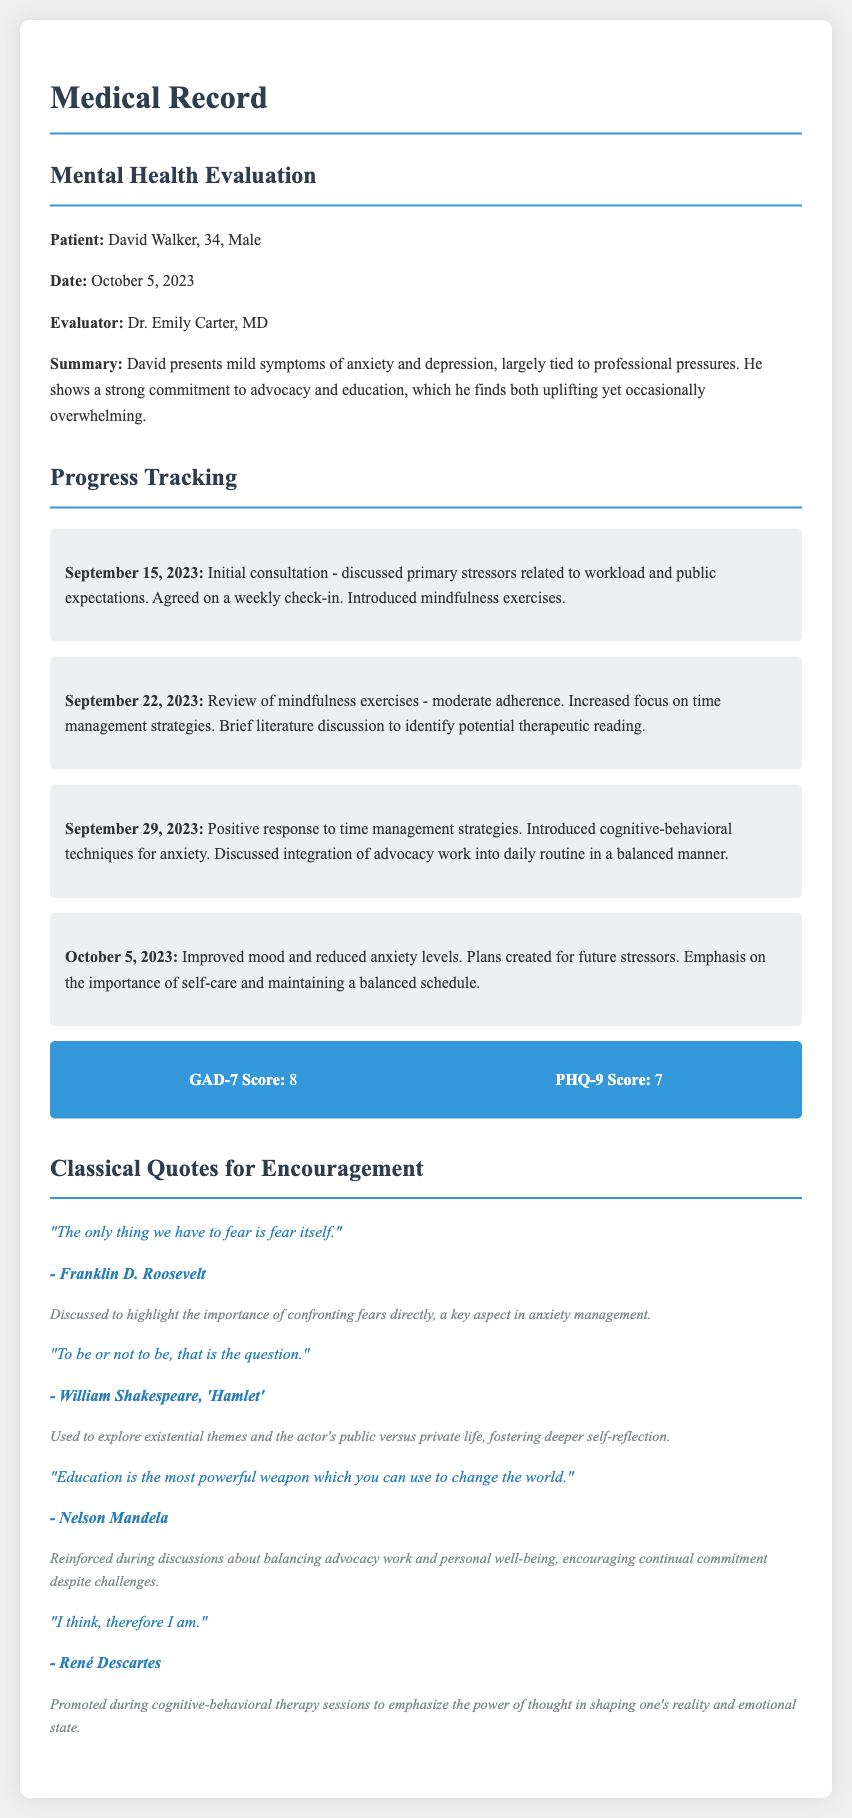What is the patient's name? The patient's name is mentioned in the evaluation section as David Walker.
Answer: David Walker Who conducted the mental health evaluation? The evaluator who conducted the mental health evaluation is noted in the document.
Answer: Dr. Emily Carter What was the GAD-7 score? The GAD-7 score is specifically listed in the scores section of the progress tracking.
Answer: 8 What date was the initial consultation? The date for the initial consultation is presented under the progress tracking section.
Answer: September 15, 2023 What is the main theme of the quote by Franklin D. Roosevelt? The quote by Franklin D. Roosevelt highlights the importance of confronting fears directly in anxiety management.
Answer: Confronting fears How did the patient's mood change by October 5, 2023? The document notes that there was an improvement in the patient's mood and reduction in anxiety levels by this date.
Answer: Improved mood What literary work is referenced in the quote "To be or not to be"? The quote is attributed to a specific literary work centered on existential themes.
Answer: Hamlet What topic was emphasized during the discussions in relation to advocacy work? The emphasis was on maintaining personal well-being while balancing advocacy work.
Answer: Personal well-being 